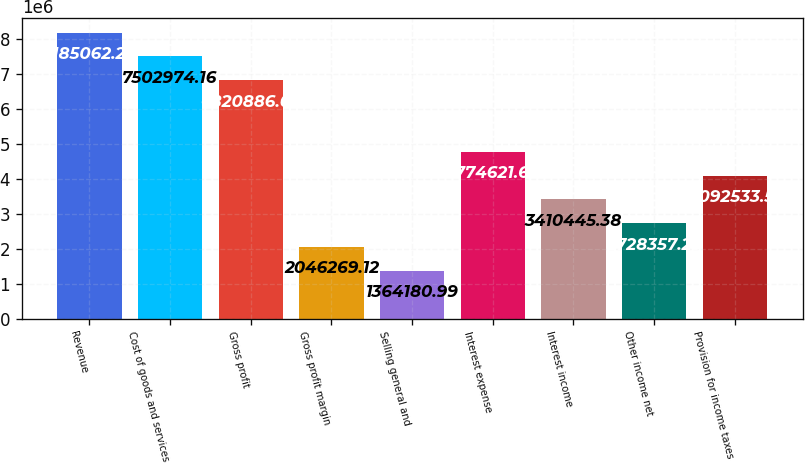<chart> <loc_0><loc_0><loc_500><loc_500><bar_chart><fcel>Revenue<fcel>Cost of goods and services<fcel>Gross profit<fcel>Gross profit margin<fcel>Selling general and<fcel>Interest expense<fcel>Interest income<fcel>Other income net<fcel>Provision for income taxes<nl><fcel>8.18506e+06<fcel>7.50297e+06<fcel>6.82089e+06<fcel>2.04627e+06<fcel>1.36418e+06<fcel>4.77462e+06<fcel>3.41045e+06<fcel>2.72836e+06<fcel>4.09253e+06<nl></chart> 